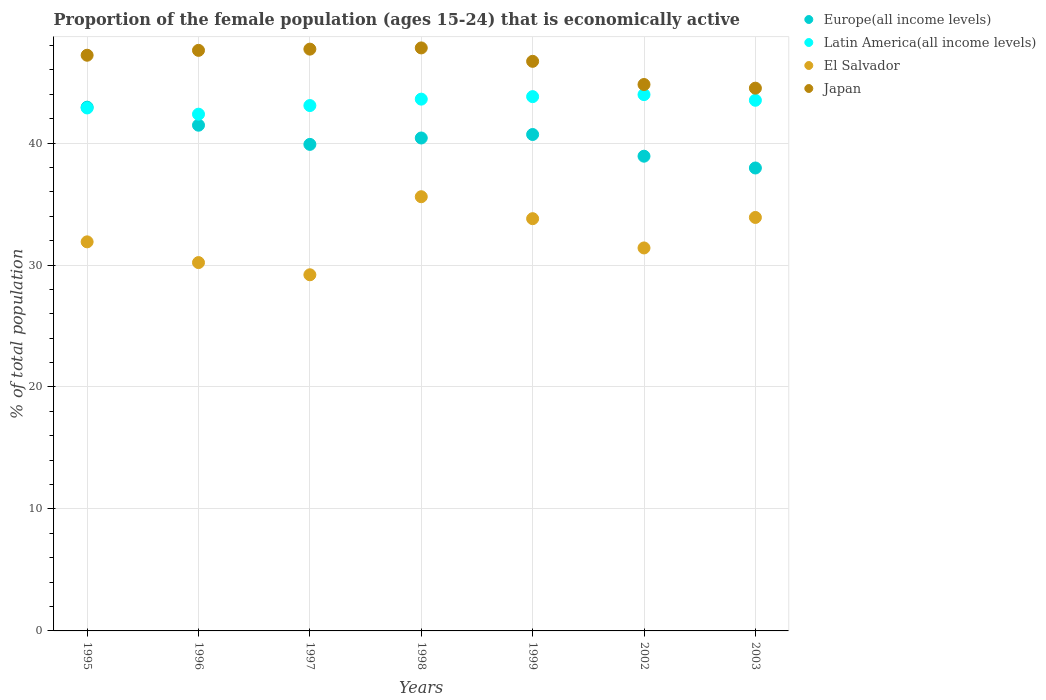How many different coloured dotlines are there?
Provide a short and direct response. 4. Is the number of dotlines equal to the number of legend labels?
Offer a very short reply. Yes. What is the proportion of the female population that is economically active in Latin America(all income levels) in 1996?
Give a very brief answer. 42.37. Across all years, what is the maximum proportion of the female population that is economically active in El Salvador?
Offer a very short reply. 35.6. Across all years, what is the minimum proportion of the female population that is economically active in El Salvador?
Offer a very short reply. 29.2. What is the total proportion of the female population that is economically active in Japan in the graph?
Keep it short and to the point. 326.3. What is the difference between the proportion of the female population that is economically active in Europe(all income levels) in 1996 and that in 1997?
Your response must be concise. 1.57. What is the difference between the proportion of the female population that is economically active in Europe(all income levels) in 2003 and the proportion of the female population that is economically active in Japan in 1999?
Your response must be concise. -8.74. What is the average proportion of the female population that is economically active in Latin America(all income levels) per year?
Offer a terse response. 43.31. In the year 1995, what is the difference between the proportion of the female population that is economically active in Japan and proportion of the female population that is economically active in Europe(all income levels)?
Your answer should be compact. 4.26. In how many years, is the proportion of the female population that is economically active in Europe(all income levels) greater than 10 %?
Offer a very short reply. 7. What is the ratio of the proportion of the female population that is economically active in Europe(all income levels) in 1996 to that in 1999?
Your answer should be compact. 1.02. What is the difference between the highest and the second highest proportion of the female population that is economically active in Europe(all income levels)?
Give a very brief answer. 1.48. What is the difference between the highest and the lowest proportion of the female population that is economically active in Latin America(all income levels)?
Your answer should be compact. 1.6. Is the sum of the proportion of the female population that is economically active in Europe(all income levels) in 1996 and 2002 greater than the maximum proportion of the female population that is economically active in El Salvador across all years?
Keep it short and to the point. Yes. Is it the case that in every year, the sum of the proportion of the female population that is economically active in Japan and proportion of the female population that is economically active in El Salvador  is greater than the sum of proportion of the female population that is economically active in Europe(all income levels) and proportion of the female population that is economically active in Latin America(all income levels)?
Offer a terse response. No. Is it the case that in every year, the sum of the proportion of the female population that is economically active in Japan and proportion of the female population that is economically active in El Salvador  is greater than the proportion of the female population that is economically active in Europe(all income levels)?
Make the answer very short. Yes. Does the proportion of the female population that is economically active in El Salvador monotonically increase over the years?
Your answer should be very brief. No. Is the proportion of the female population that is economically active in Japan strictly greater than the proportion of the female population that is economically active in Europe(all income levels) over the years?
Keep it short and to the point. Yes. Is the proportion of the female population that is economically active in El Salvador strictly less than the proportion of the female population that is economically active in Japan over the years?
Offer a terse response. Yes. How many dotlines are there?
Offer a very short reply. 4. How many years are there in the graph?
Your answer should be compact. 7. What is the difference between two consecutive major ticks on the Y-axis?
Offer a terse response. 10. Does the graph contain any zero values?
Give a very brief answer. No. Does the graph contain grids?
Give a very brief answer. Yes. Where does the legend appear in the graph?
Give a very brief answer. Top right. How many legend labels are there?
Your response must be concise. 4. What is the title of the graph?
Provide a short and direct response. Proportion of the female population (ages 15-24) that is economically active. Does "China" appear as one of the legend labels in the graph?
Your answer should be compact. No. What is the label or title of the Y-axis?
Provide a short and direct response. % of total population. What is the % of total population of Europe(all income levels) in 1995?
Your response must be concise. 42.94. What is the % of total population of Latin America(all income levels) in 1995?
Keep it short and to the point. 42.88. What is the % of total population of El Salvador in 1995?
Provide a short and direct response. 31.9. What is the % of total population in Japan in 1995?
Ensure brevity in your answer.  47.2. What is the % of total population of Europe(all income levels) in 1996?
Your answer should be very brief. 41.46. What is the % of total population of Latin America(all income levels) in 1996?
Make the answer very short. 42.37. What is the % of total population in El Salvador in 1996?
Provide a short and direct response. 30.2. What is the % of total population in Japan in 1996?
Your answer should be very brief. 47.6. What is the % of total population of Europe(all income levels) in 1997?
Make the answer very short. 39.89. What is the % of total population in Latin America(all income levels) in 1997?
Give a very brief answer. 43.07. What is the % of total population of El Salvador in 1997?
Ensure brevity in your answer.  29.2. What is the % of total population in Japan in 1997?
Make the answer very short. 47.7. What is the % of total population in Europe(all income levels) in 1998?
Keep it short and to the point. 40.41. What is the % of total population in Latin America(all income levels) in 1998?
Make the answer very short. 43.6. What is the % of total population of El Salvador in 1998?
Ensure brevity in your answer.  35.6. What is the % of total population of Japan in 1998?
Keep it short and to the point. 47.8. What is the % of total population in Europe(all income levels) in 1999?
Your answer should be very brief. 40.7. What is the % of total population in Latin America(all income levels) in 1999?
Keep it short and to the point. 43.81. What is the % of total population of El Salvador in 1999?
Ensure brevity in your answer.  33.8. What is the % of total population of Japan in 1999?
Offer a very short reply. 46.7. What is the % of total population of Europe(all income levels) in 2002?
Ensure brevity in your answer.  38.92. What is the % of total population in Latin America(all income levels) in 2002?
Your answer should be compact. 43.97. What is the % of total population in El Salvador in 2002?
Your answer should be compact. 31.4. What is the % of total population in Japan in 2002?
Give a very brief answer. 44.8. What is the % of total population in Europe(all income levels) in 2003?
Make the answer very short. 37.96. What is the % of total population in Latin America(all income levels) in 2003?
Make the answer very short. 43.51. What is the % of total population in El Salvador in 2003?
Provide a succinct answer. 33.9. What is the % of total population in Japan in 2003?
Offer a very short reply. 44.5. Across all years, what is the maximum % of total population in Europe(all income levels)?
Provide a succinct answer. 42.94. Across all years, what is the maximum % of total population in Latin America(all income levels)?
Offer a very short reply. 43.97. Across all years, what is the maximum % of total population in El Salvador?
Provide a short and direct response. 35.6. Across all years, what is the maximum % of total population of Japan?
Make the answer very short. 47.8. Across all years, what is the minimum % of total population of Europe(all income levels)?
Make the answer very short. 37.96. Across all years, what is the minimum % of total population in Latin America(all income levels)?
Your answer should be very brief. 42.37. Across all years, what is the minimum % of total population in El Salvador?
Make the answer very short. 29.2. Across all years, what is the minimum % of total population of Japan?
Make the answer very short. 44.5. What is the total % of total population in Europe(all income levels) in the graph?
Keep it short and to the point. 282.29. What is the total % of total population in Latin America(all income levels) in the graph?
Ensure brevity in your answer.  303.2. What is the total % of total population in El Salvador in the graph?
Your response must be concise. 226. What is the total % of total population of Japan in the graph?
Provide a succinct answer. 326.3. What is the difference between the % of total population in Europe(all income levels) in 1995 and that in 1996?
Your answer should be very brief. 1.48. What is the difference between the % of total population in Latin America(all income levels) in 1995 and that in 1996?
Ensure brevity in your answer.  0.51. What is the difference between the % of total population of Japan in 1995 and that in 1996?
Offer a very short reply. -0.4. What is the difference between the % of total population in Europe(all income levels) in 1995 and that in 1997?
Give a very brief answer. 3.05. What is the difference between the % of total population of Latin America(all income levels) in 1995 and that in 1997?
Keep it short and to the point. -0.2. What is the difference between the % of total population in El Salvador in 1995 and that in 1997?
Give a very brief answer. 2.7. What is the difference between the % of total population in Japan in 1995 and that in 1997?
Provide a succinct answer. -0.5. What is the difference between the % of total population in Europe(all income levels) in 1995 and that in 1998?
Provide a short and direct response. 2.53. What is the difference between the % of total population in Latin America(all income levels) in 1995 and that in 1998?
Keep it short and to the point. -0.72. What is the difference between the % of total population of Japan in 1995 and that in 1998?
Ensure brevity in your answer.  -0.6. What is the difference between the % of total population of Europe(all income levels) in 1995 and that in 1999?
Your answer should be compact. 2.24. What is the difference between the % of total population of Latin America(all income levels) in 1995 and that in 1999?
Provide a short and direct response. -0.93. What is the difference between the % of total population in Europe(all income levels) in 1995 and that in 2002?
Your response must be concise. 4.02. What is the difference between the % of total population in Latin America(all income levels) in 1995 and that in 2002?
Provide a short and direct response. -1.09. What is the difference between the % of total population of Japan in 1995 and that in 2002?
Provide a succinct answer. 2.4. What is the difference between the % of total population of Europe(all income levels) in 1995 and that in 2003?
Provide a succinct answer. 4.99. What is the difference between the % of total population of Latin America(all income levels) in 1995 and that in 2003?
Give a very brief answer. -0.63. What is the difference between the % of total population of El Salvador in 1995 and that in 2003?
Ensure brevity in your answer.  -2. What is the difference between the % of total population in Europe(all income levels) in 1996 and that in 1997?
Offer a very short reply. 1.57. What is the difference between the % of total population in Latin America(all income levels) in 1996 and that in 1997?
Your response must be concise. -0.71. What is the difference between the % of total population in Europe(all income levels) in 1996 and that in 1998?
Your answer should be compact. 1.05. What is the difference between the % of total population in Latin America(all income levels) in 1996 and that in 1998?
Provide a short and direct response. -1.23. What is the difference between the % of total population in Japan in 1996 and that in 1998?
Provide a succinct answer. -0.2. What is the difference between the % of total population of Europe(all income levels) in 1996 and that in 1999?
Your response must be concise. 0.76. What is the difference between the % of total population in Latin America(all income levels) in 1996 and that in 1999?
Provide a succinct answer. -1.44. What is the difference between the % of total population in El Salvador in 1996 and that in 1999?
Offer a terse response. -3.6. What is the difference between the % of total population of Japan in 1996 and that in 1999?
Provide a succinct answer. 0.9. What is the difference between the % of total population of Europe(all income levels) in 1996 and that in 2002?
Give a very brief answer. 2.54. What is the difference between the % of total population in Latin America(all income levels) in 1996 and that in 2002?
Your answer should be very brief. -1.6. What is the difference between the % of total population in El Salvador in 1996 and that in 2002?
Make the answer very short. -1.2. What is the difference between the % of total population in Japan in 1996 and that in 2002?
Your answer should be very brief. 2.8. What is the difference between the % of total population in Europe(all income levels) in 1996 and that in 2003?
Provide a short and direct response. 3.51. What is the difference between the % of total population of Latin America(all income levels) in 1996 and that in 2003?
Make the answer very short. -1.14. What is the difference between the % of total population in El Salvador in 1996 and that in 2003?
Make the answer very short. -3.7. What is the difference between the % of total population in Japan in 1996 and that in 2003?
Your response must be concise. 3.1. What is the difference between the % of total population of Europe(all income levels) in 1997 and that in 1998?
Your answer should be very brief. -0.52. What is the difference between the % of total population of Latin America(all income levels) in 1997 and that in 1998?
Give a very brief answer. -0.53. What is the difference between the % of total population of El Salvador in 1997 and that in 1998?
Your answer should be very brief. -6.4. What is the difference between the % of total population of Japan in 1997 and that in 1998?
Give a very brief answer. -0.1. What is the difference between the % of total population of Europe(all income levels) in 1997 and that in 1999?
Your answer should be compact. -0.81. What is the difference between the % of total population in Latin America(all income levels) in 1997 and that in 1999?
Your answer should be very brief. -0.73. What is the difference between the % of total population of El Salvador in 1997 and that in 1999?
Your answer should be compact. -4.6. What is the difference between the % of total population of Japan in 1997 and that in 1999?
Your answer should be compact. 1. What is the difference between the % of total population in Europe(all income levels) in 1997 and that in 2002?
Make the answer very short. 0.97. What is the difference between the % of total population of Latin America(all income levels) in 1997 and that in 2002?
Give a very brief answer. -0.9. What is the difference between the % of total population in El Salvador in 1997 and that in 2002?
Your response must be concise. -2.2. What is the difference between the % of total population in Japan in 1997 and that in 2002?
Your answer should be very brief. 2.9. What is the difference between the % of total population of Europe(all income levels) in 1997 and that in 2003?
Provide a short and direct response. 1.93. What is the difference between the % of total population in Latin America(all income levels) in 1997 and that in 2003?
Ensure brevity in your answer.  -0.43. What is the difference between the % of total population of El Salvador in 1997 and that in 2003?
Ensure brevity in your answer.  -4.7. What is the difference between the % of total population in Japan in 1997 and that in 2003?
Provide a short and direct response. 3.2. What is the difference between the % of total population in Europe(all income levels) in 1998 and that in 1999?
Give a very brief answer. -0.29. What is the difference between the % of total population in Latin America(all income levels) in 1998 and that in 1999?
Make the answer very short. -0.21. What is the difference between the % of total population in Japan in 1998 and that in 1999?
Your answer should be very brief. 1.1. What is the difference between the % of total population in Europe(all income levels) in 1998 and that in 2002?
Your response must be concise. 1.49. What is the difference between the % of total population in Latin America(all income levels) in 1998 and that in 2002?
Ensure brevity in your answer.  -0.37. What is the difference between the % of total population of El Salvador in 1998 and that in 2002?
Ensure brevity in your answer.  4.2. What is the difference between the % of total population in Europe(all income levels) in 1998 and that in 2003?
Your answer should be compact. 2.46. What is the difference between the % of total population in Latin America(all income levels) in 1998 and that in 2003?
Your answer should be compact. 0.09. What is the difference between the % of total population in El Salvador in 1998 and that in 2003?
Provide a succinct answer. 1.7. What is the difference between the % of total population in Japan in 1998 and that in 2003?
Provide a succinct answer. 3.3. What is the difference between the % of total population in Europe(all income levels) in 1999 and that in 2002?
Offer a very short reply. 1.78. What is the difference between the % of total population of Latin America(all income levels) in 1999 and that in 2002?
Offer a terse response. -0.17. What is the difference between the % of total population of El Salvador in 1999 and that in 2002?
Provide a succinct answer. 2.4. What is the difference between the % of total population in Japan in 1999 and that in 2002?
Your answer should be very brief. 1.9. What is the difference between the % of total population of Europe(all income levels) in 1999 and that in 2003?
Keep it short and to the point. 2.75. What is the difference between the % of total population of Latin America(all income levels) in 1999 and that in 2003?
Give a very brief answer. 0.3. What is the difference between the % of total population of Europe(all income levels) in 2002 and that in 2003?
Your response must be concise. 0.97. What is the difference between the % of total population of Latin America(all income levels) in 2002 and that in 2003?
Your response must be concise. 0.46. What is the difference between the % of total population in Japan in 2002 and that in 2003?
Your answer should be compact. 0.3. What is the difference between the % of total population in Europe(all income levels) in 1995 and the % of total population in Latin America(all income levels) in 1996?
Provide a succinct answer. 0.57. What is the difference between the % of total population in Europe(all income levels) in 1995 and the % of total population in El Salvador in 1996?
Your answer should be very brief. 12.74. What is the difference between the % of total population of Europe(all income levels) in 1995 and the % of total population of Japan in 1996?
Provide a succinct answer. -4.66. What is the difference between the % of total population of Latin America(all income levels) in 1995 and the % of total population of El Salvador in 1996?
Provide a succinct answer. 12.68. What is the difference between the % of total population of Latin America(all income levels) in 1995 and the % of total population of Japan in 1996?
Make the answer very short. -4.72. What is the difference between the % of total population in El Salvador in 1995 and the % of total population in Japan in 1996?
Offer a very short reply. -15.7. What is the difference between the % of total population of Europe(all income levels) in 1995 and the % of total population of Latin America(all income levels) in 1997?
Provide a succinct answer. -0.13. What is the difference between the % of total population of Europe(all income levels) in 1995 and the % of total population of El Salvador in 1997?
Keep it short and to the point. 13.74. What is the difference between the % of total population in Europe(all income levels) in 1995 and the % of total population in Japan in 1997?
Your answer should be very brief. -4.76. What is the difference between the % of total population of Latin America(all income levels) in 1995 and the % of total population of El Salvador in 1997?
Your answer should be very brief. 13.68. What is the difference between the % of total population of Latin America(all income levels) in 1995 and the % of total population of Japan in 1997?
Make the answer very short. -4.82. What is the difference between the % of total population of El Salvador in 1995 and the % of total population of Japan in 1997?
Provide a succinct answer. -15.8. What is the difference between the % of total population of Europe(all income levels) in 1995 and the % of total population of Latin America(all income levels) in 1998?
Keep it short and to the point. -0.66. What is the difference between the % of total population of Europe(all income levels) in 1995 and the % of total population of El Salvador in 1998?
Provide a succinct answer. 7.34. What is the difference between the % of total population of Europe(all income levels) in 1995 and the % of total population of Japan in 1998?
Keep it short and to the point. -4.86. What is the difference between the % of total population in Latin America(all income levels) in 1995 and the % of total population in El Salvador in 1998?
Provide a succinct answer. 7.28. What is the difference between the % of total population in Latin America(all income levels) in 1995 and the % of total population in Japan in 1998?
Provide a short and direct response. -4.92. What is the difference between the % of total population of El Salvador in 1995 and the % of total population of Japan in 1998?
Offer a terse response. -15.9. What is the difference between the % of total population of Europe(all income levels) in 1995 and the % of total population of Latin America(all income levels) in 1999?
Ensure brevity in your answer.  -0.87. What is the difference between the % of total population in Europe(all income levels) in 1995 and the % of total population in El Salvador in 1999?
Your answer should be compact. 9.14. What is the difference between the % of total population in Europe(all income levels) in 1995 and the % of total population in Japan in 1999?
Ensure brevity in your answer.  -3.76. What is the difference between the % of total population of Latin America(all income levels) in 1995 and the % of total population of El Salvador in 1999?
Offer a terse response. 9.08. What is the difference between the % of total population of Latin America(all income levels) in 1995 and the % of total population of Japan in 1999?
Provide a short and direct response. -3.82. What is the difference between the % of total population of El Salvador in 1995 and the % of total population of Japan in 1999?
Your response must be concise. -14.8. What is the difference between the % of total population in Europe(all income levels) in 1995 and the % of total population in Latin America(all income levels) in 2002?
Your answer should be compact. -1.03. What is the difference between the % of total population in Europe(all income levels) in 1995 and the % of total population in El Salvador in 2002?
Your response must be concise. 11.54. What is the difference between the % of total population of Europe(all income levels) in 1995 and the % of total population of Japan in 2002?
Make the answer very short. -1.86. What is the difference between the % of total population of Latin America(all income levels) in 1995 and the % of total population of El Salvador in 2002?
Your answer should be compact. 11.48. What is the difference between the % of total population in Latin America(all income levels) in 1995 and the % of total population in Japan in 2002?
Give a very brief answer. -1.92. What is the difference between the % of total population of Europe(all income levels) in 1995 and the % of total population of Latin America(all income levels) in 2003?
Make the answer very short. -0.57. What is the difference between the % of total population in Europe(all income levels) in 1995 and the % of total population in El Salvador in 2003?
Your answer should be compact. 9.04. What is the difference between the % of total population of Europe(all income levels) in 1995 and the % of total population of Japan in 2003?
Offer a terse response. -1.56. What is the difference between the % of total population of Latin America(all income levels) in 1995 and the % of total population of El Salvador in 2003?
Provide a succinct answer. 8.98. What is the difference between the % of total population of Latin America(all income levels) in 1995 and the % of total population of Japan in 2003?
Give a very brief answer. -1.62. What is the difference between the % of total population in El Salvador in 1995 and the % of total population in Japan in 2003?
Your response must be concise. -12.6. What is the difference between the % of total population in Europe(all income levels) in 1996 and the % of total population in Latin America(all income levels) in 1997?
Keep it short and to the point. -1.61. What is the difference between the % of total population of Europe(all income levels) in 1996 and the % of total population of El Salvador in 1997?
Offer a terse response. 12.26. What is the difference between the % of total population of Europe(all income levels) in 1996 and the % of total population of Japan in 1997?
Give a very brief answer. -6.24. What is the difference between the % of total population of Latin America(all income levels) in 1996 and the % of total population of El Salvador in 1997?
Your response must be concise. 13.17. What is the difference between the % of total population of Latin America(all income levels) in 1996 and the % of total population of Japan in 1997?
Provide a succinct answer. -5.33. What is the difference between the % of total population of El Salvador in 1996 and the % of total population of Japan in 1997?
Give a very brief answer. -17.5. What is the difference between the % of total population in Europe(all income levels) in 1996 and the % of total population in Latin America(all income levels) in 1998?
Provide a short and direct response. -2.14. What is the difference between the % of total population of Europe(all income levels) in 1996 and the % of total population of El Salvador in 1998?
Provide a short and direct response. 5.86. What is the difference between the % of total population of Europe(all income levels) in 1996 and the % of total population of Japan in 1998?
Provide a short and direct response. -6.34. What is the difference between the % of total population in Latin America(all income levels) in 1996 and the % of total population in El Salvador in 1998?
Offer a very short reply. 6.77. What is the difference between the % of total population of Latin America(all income levels) in 1996 and the % of total population of Japan in 1998?
Your response must be concise. -5.43. What is the difference between the % of total population of El Salvador in 1996 and the % of total population of Japan in 1998?
Offer a very short reply. -17.6. What is the difference between the % of total population in Europe(all income levels) in 1996 and the % of total population in Latin America(all income levels) in 1999?
Provide a succinct answer. -2.34. What is the difference between the % of total population in Europe(all income levels) in 1996 and the % of total population in El Salvador in 1999?
Give a very brief answer. 7.66. What is the difference between the % of total population of Europe(all income levels) in 1996 and the % of total population of Japan in 1999?
Give a very brief answer. -5.24. What is the difference between the % of total population of Latin America(all income levels) in 1996 and the % of total population of El Salvador in 1999?
Make the answer very short. 8.57. What is the difference between the % of total population in Latin America(all income levels) in 1996 and the % of total population in Japan in 1999?
Your answer should be compact. -4.33. What is the difference between the % of total population of El Salvador in 1996 and the % of total population of Japan in 1999?
Provide a short and direct response. -16.5. What is the difference between the % of total population of Europe(all income levels) in 1996 and the % of total population of Latin America(all income levels) in 2002?
Your answer should be very brief. -2.51. What is the difference between the % of total population in Europe(all income levels) in 1996 and the % of total population in El Salvador in 2002?
Offer a very short reply. 10.06. What is the difference between the % of total population of Europe(all income levels) in 1996 and the % of total population of Japan in 2002?
Keep it short and to the point. -3.34. What is the difference between the % of total population of Latin America(all income levels) in 1996 and the % of total population of El Salvador in 2002?
Ensure brevity in your answer.  10.97. What is the difference between the % of total population in Latin America(all income levels) in 1996 and the % of total population in Japan in 2002?
Your response must be concise. -2.43. What is the difference between the % of total population of El Salvador in 1996 and the % of total population of Japan in 2002?
Make the answer very short. -14.6. What is the difference between the % of total population of Europe(all income levels) in 1996 and the % of total population of Latin America(all income levels) in 2003?
Ensure brevity in your answer.  -2.04. What is the difference between the % of total population in Europe(all income levels) in 1996 and the % of total population in El Salvador in 2003?
Offer a terse response. 7.56. What is the difference between the % of total population of Europe(all income levels) in 1996 and the % of total population of Japan in 2003?
Your answer should be compact. -3.04. What is the difference between the % of total population of Latin America(all income levels) in 1996 and the % of total population of El Salvador in 2003?
Offer a very short reply. 8.47. What is the difference between the % of total population in Latin America(all income levels) in 1996 and the % of total population in Japan in 2003?
Your answer should be compact. -2.13. What is the difference between the % of total population in El Salvador in 1996 and the % of total population in Japan in 2003?
Ensure brevity in your answer.  -14.3. What is the difference between the % of total population in Europe(all income levels) in 1997 and the % of total population in Latin America(all income levels) in 1998?
Offer a terse response. -3.71. What is the difference between the % of total population of Europe(all income levels) in 1997 and the % of total population of El Salvador in 1998?
Ensure brevity in your answer.  4.29. What is the difference between the % of total population of Europe(all income levels) in 1997 and the % of total population of Japan in 1998?
Keep it short and to the point. -7.91. What is the difference between the % of total population in Latin America(all income levels) in 1997 and the % of total population in El Salvador in 1998?
Offer a terse response. 7.47. What is the difference between the % of total population in Latin America(all income levels) in 1997 and the % of total population in Japan in 1998?
Offer a very short reply. -4.73. What is the difference between the % of total population in El Salvador in 1997 and the % of total population in Japan in 1998?
Provide a short and direct response. -18.6. What is the difference between the % of total population of Europe(all income levels) in 1997 and the % of total population of Latin America(all income levels) in 1999?
Provide a short and direct response. -3.92. What is the difference between the % of total population of Europe(all income levels) in 1997 and the % of total population of El Salvador in 1999?
Provide a short and direct response. 6.09. What is the difference between the % of total population in Europe(all income levels) in 1997 and the % of total population in Japan in 1999?
Your response must be concise. -6.81. What is the difference between the % of total population in Latin America(all income levels) in 1997 and the % of total population in El Salvador in 1999?
Your response must be concise. 9.27. What is the difference between the % of total population of Latin America(all income levels) in 1997 and the % of total population of Japan in 1999?
Give a very brief answer. -3.63. What is the difference between the % of total population in El Salvador in 1997 and the % of total population in Japan in 1999?
Make the answer very short. -17.5. What is the difference between the % of total population in Europe(all income levels) in 1997 and the % of total population in Latin America(all income levels) in 2002?
Offer a very short reply. -4.08. What is the difference between the % of total population in Europe(all income levels) in 1997 and the % of total population in El Salvador in 2002?
Offer a terse response. 8.49. What is the difference between the % of total population in Europe(all income levels) in 1997 and the % of total population in Japan in 2002?
Give a very brief answer. -4.91. What is the difference between the % of total population of Latin America(all income levels) in 1997 and the % of total population of El Salvador in 2002?
Your answer should be compact. 11.67. What is the difference between the % of total population in Latin America(all income levels) in 1997 and the % of total population in Japan in 2002?
Offer a terse response. -1.73. What is the difference between the % of total population of El Salvador in 1997 and the % of total population of Japan in 2002?
Give a very brief answer. -15.6. What is the difference between the % of total population in Europe(all income levels) in 1997 and the % of total population in Latin America(all income levels) in 2003?
Provide a short and direct response. -3.62. What is the difference between the % of total population in Europe(all income levels) in 1997 and the % of total population in El Salvador in 2003?
Keep it short and to the point. 5.99. What is the difference between the % of total population of Europe(all income levels) in 1997 and the % of total population of Japan in 2003?
Ensure brevity in your answer.  -4.61. What is the difference between the % of total population in Latin America(all income levels) in 1997 and the % of total population in El Salvador in 2003?
Your response must be concise. 9.17. What is the difference between the % of total population in Latin America(all income levels) in 1997 and the % of total population in Japan in 2003?
Provide a succinct answer. -1.43. What is the difference between the % of total population of El Salvador in 1997 and the % of total population of Japan in 2003?
Your answer should be very brief. -15.3. What is the difference between the % of total population in Europe(all income levels) in 1998 and the % of total population in Latin America(all income levels) in 1999?
Your answer should be very brief. -3.39. What is the difference between the % of total population in Europe(all income levels) in 1998 and the % of total population in El Salvador in 1999?
Your answer should be compact. 6.61. What is the difference between the % of total population of Europe(all income levels) in 1998 and the % of total population of Japan in 1999?
Provide a short and direct response. -6.29. What is the difference between the % of total population in Latin America(all income levels) in 1998 and the % of total population in El Salvador in 1999?
Offer a very short reply. 9.8. What is the difference between the % of total population of Latin America(all income levels) in 1998 and the % of total population of Japan in 1999?
Your answer should be very brief. -3.1. What is the difference between the % of total population in Europe(all income levels) in 1998 and the % of total population in Latin America(all income levels) in 2002?
Provide a short and direct response. -3.56. What is the difference between the % of total population of Europe(all income levels) in 1998 and the % of total population of El Salvador in 2002?
Provide a short and direct response. 9.01. What is the difference between the % of total population of Europe(all income levels) in 1998 and the % of total population of Japan in 2002?
Offer a terse response. -4.39. What is the difference between the % of total population in Latin America(all income levels) in 1998 and the % of total population in El Salvador in 2002?
Your response must be concise. 12.2. What is the difference between the % of total population of Latin America(all income levels) in 1998 and the % of total population of Japan in 2002?
Your answer should be compact. -1.2. What is the difference between the % of total population in Europe(all income levels) in 1998 and the % of total population in Latin America(all income levels) in 2003?
Give a very brief answer. -3.09. What is the difference between the % of total population in Europe(all income levels) in 1998 and the % of total population in El Salvador in 2003?
Offer a very short reply. 6.51. What is the difference between the % of total population in Europe(all income levels) in 1998 and the % of total population in Japan in 2003?
Provide a succinct answer. -4.09. What is the difference between the % of total population in Latin America(all income levels) in 1998 and the % of total population in El Salvador in 2003?
Offer a terse response. 9.7. What is the difference between the % of total population in Latin America(all income levels) in 1998 and the % of total population in Japan in 2003?
Your answer should be very brief. -0.9. What is the difference between the % of total population of El Salvador in 1998 and the % of total population of Japan in 2003?
Make the answer very short. -8.9. What is the difference between the % of total population of Europe(all income levels) in 1999 and the % of total population of Latin America(all income levels) in 2002?
Ensure brevity in your answer.  -3.27. What is the difference between the % of total population in Europe(all income levels) in 1999 and the % of total population in El Salvador in 2002?
Offer a very short reply. 9.3. What is the difference between the % of total population in Europe(all income levels) in 1999 and the % of total population in Japan in 2002?
Your answer should be very brief. -4.1. What is the difference between the % of total population in Latin America(all income levels) in 1999 and the % of total population in El Salvador in 2002?
Your answer should be very brief. 12.41. What is the difference between the % of total population in Latin America(all income levels) in 1999 and the % of total population in Japan in 2002?
Offer a very short reply. -0.99. What is the difference between the % of total population of Europe(all income levels) in 1999 and the % of total population of Latin America(all income levels) in 2003?
Your answer should be very brief. -2.81. What is the difference between the % of total population of Europe(all income levels) in 1999 and the % of total population of El Salvador in 2003?
Provide a succinct answer. 6.8. What is the difference between the % of total population in Europe(all income levels) in 1999 and the % of total population in Japan in 2003?
Your answer should be compact. -3.8. What is the difference between the % of total population of Latin America(all income levels) in 1999 and the % of total population of El Salvador in 2003?
Your response must be concise. 9.91. What is the difference between the % of total population in Latin America(all income levels) in 1999 and the % of total population in Japan in 2003?
Offer a terse response. -0.69. What is the difference between the % of total population in El Salvador in 1999 and the % of total population in Japan in 2003?
Give a very brief answer. -10.7. What is the difference between the % of total population in Europe(all income levels) in 2002 and the % of total population in Latin America(all income levels) in 2003?
Your response must be concise. -4.58. What is the difference between the % of total population of Europe(all income levels) in 2002 and the % of total population of El Salvador in 2003?
Your answer should be very brief. 5.02. What is the difference between the % of total population in Europe(all income levels) in 2002 and the % of total population in Japan in 2003?
Give a very brief answer. -5.58. What is the difference between the % of total population of Latin America(all income levels) in 2002 and the % of total population of El Salvador in 2003?
Offer a very short reply. 10.07. What is the difference between the % of total population in Latin America(all income levels) in 2002 and the % of total population in Japan in 2003?
Ensure brevity in your answer.  -0.53. What is the average % of total population in Europe(all income levels) per year?
Offer a terse response. 40.33. What is the average % of total population in Latin America(all income levels) per year?
Offer a very short reply. 43.31. What is the average % of total population of El Salvador per year?
Make the answer very short. 32.29. What is the average % of total population in Japan per year?
Ensure brevity in your answer.  46.61. In the year 1995, what is the difference between the % of total population in Europe(all income levels) and % of total population in Latin America(all income levels)?
Give a very brief answer. 0.06. In the year 1995, what is the difference between the % of total population in Europe(all income levels) and % of total population in El Salvador?
Your answer should be very brief. 11.04. In the year 1995, what is the difference between the % of total population of Europe(all income levels) and % of total population of Japan?
Your response must be concise. -4.26. In the year 1995, what is the difference between the % of total population of Latin America(all income levels) and % of total population of El Salvador?
Provide a short and direct response. 10.98. In the year 1995, what is the difference between the % of total population in Latin America(all income levels) and % of total population in Japan?
Provide a short and direct response. -4.32. In the year 1995, what is the difference between the % of total population in El Salvador and % of total population in Japan?
Provide a succinct answer. -15.3. In the year 1996, what is the difference between the % of total population of Europe(all income levels) and % of total population of Latin America(all income levels)?
Your response must be concise. -0.9. In the year 1996, what is the difference between the % of total population in Europe(all income levels) and % of total population in El Salvador?
Ensure brevity in your answer.  11.26. In the year 1996, what is the difference between the % of total population of Europe(all income levels) and % of total population of Japan?
Offer a terse response. -6.14. In the year 1996, what is the difference between the % of total population of Latin America(all income levels) and % of total population of El Salvador?
Ensure brevity in your answer.  12.17. In the year 1996, what is the difference between the % of total population of Latin America(all income levels) and % of total population of Japan?
Ensure brevity in your answer.  -5.23. In the year 1996, what is the difference between the % of total population of El Salvador and % of total population of Japan?
Provide a succinct answer. -17.4. In the year 1997, what is the difference between the % of total population of Europe(all income levels) and % of total population of Latin America(all income levels)?
Ensure brevity in your answer.  -3.18. In the year 1997, what is the difference between the % of total population in Europe(all income levels) and % of total population in El Salvador?
Offer a terse response. 10.69. In the year 1997, what is the difference between the % of total population of Europe(all income levels) and % of total population of Japan?
Ensure brevity in your answer.  -7.81. In the year 1997, what is the difference between the % of total population in Latin America(all income levels) and % of total population in El Salvador?
Your response must be concise. 13.87. In the year 1997, what is the difference between the % of total population of Latin America(all income levels) and % of total population of Japan?
Your answer should be compact. -4.63. In the year 1997, what is the difference between the % of total population of El Salvador and % of total population of Japan?
Provide a succinct answer. -18.5. In the year 1998, what is the difference between the % of total population of Europe(all income levels) and % of total population of Latin America(all income levels)?
Ensure brevity in your answer.  -3.19. In the year 1998, what is the difference between the % of total population of Europe(all income levels) and % of total population of El Salvador?
Your response must be concise. 4.81. In the year 1998, what is the difference between the % of total population in Europe(all income levels) and % of total population in Japan?
Make the answer very short. -7.39. In the year 1998, what is the difference between the % of total population of Latin America(all income levels) and % of total population of El Salvador?
Make the answer very short. 8. In the year 1998, what is the difference between the % of total population in Latin America(all income levels) and % of total population in Japan?
Keep it short and to the point. -4.2. In the year 1998, what is the difference between the % of total population of El Salvador and % of total population of Japan?
Provide a short and direct response. -12.2. In the year 1999, what is the difference between the % of total population in Europe(all income levels) and % of total population in Latin America(all income levels)?
Make the answer very short. -3.11. In the year 1999, what is the difference between the % of total population in Europe(all income levels) and % of total population in El Salvador?
Offer a very short reply. 6.9. In the year 1999, what is the difference between the % of total population of Europe(all income levels) and % of total population of Japan?
Provide a short and direct response. -6. In the year 1999, what is the difference between the % of total population in Latin America(all income levels) and % of total population in El Salvador?
Provide a short and direct response. 10.01. In the year 1999, what is the difference between the % of total population of Latin America(all income levels) and % of total population of Japan?
Your response must be concise. -2.89. In the year 1999, what is the difference between the % of total population in El Salvador and % of total population in Japan?
Offer a very short reply. -12.9. In the year 2002, what is the difference between the % of total population in Europe(all income levels) and % of total population in Latin America(all income levels)?
Keep it short and to the point. -5.05. In the year 2002, what is the difference between the % of total population of Europe(all income levels) and % of total population of El Salvador?
Your answer should be very brief. 7.52. In the year 2002, what is the difference between the % of total population of Europe(all income levels) and % of total population of Japan?
Provide a short and direct response. -5.88. In the year 2002, what is the difference between the % of total population of Latin America(all income levels) and % of total population of El Salvador?
Your answer should be very brief. 12.57. In the year 2002, what is the difference between the % of total population in Latin America(all income levels) and % of total population in Japan?
Your answer should be very brief. -0.83. In the year 2002, what is the difference between the % of total population of El Salvador and % of total population of Japan?
Give a very brief answer. -13.4. In the year 2003, what is the difference between the % of total population in Europe(all income levels) and % of total population in Latin America(all income levels)?
Keep it short and to the point. -5.55. In the year 2003, what is the difference between the % of total population in Europe(all income levels) and % of total population in El Salvador?
Ensure brevity in your answer.  4.06. In the year 2003, what is the difference between the % of total population of Europe(all income levels) and % of total population of Japan?
Keep it short and to the point. -6.54. In the year 2003, what is the difference between the % of total population of Latin America(all income levels) and % of total population of El Salvador?
Provide a short and direct response. 9.61. In the year 2003, what is the difference between the % of total population in Latin America(all income levels) and % of total population in Japan?
Your response must be concise. -0.99. What is the ratio of the % of total population in Europe(all income levels) in 1995 to that in 1996?
Ensure brevity in your answer.  1.04. What is the ratio of the % of total population of Latin America(all income levels) in 1995 to that in 1996?
Make the answer very short. 1.01. What is the ratio of the % of total population of El Salvador in 1995 to that in 1996?
Your answer should be compact. 1.06. What is the ratio of the % of total population of Europe(all income levels) in 1995 to that in 1997?
Offer a very short reply. 1.08. What is the ratio of the % of total population of Latin America(all income levels) in 1995 to that in 1997?
Keep it short and to the point. 1. What is the ratio of the % of total population of El Salvador in 1995 to that in 1997?
Offer a terse response. 1.09. What is the ratio of the % of total population in Japan in 1995 to that in 1997?
Your answer should be very brief. 0.99. What is the ratio of the % of total population of Latin America(all income levels) in 1995 to that in 1998?
Your answer should be very brief. 0.98. What is the ratio of the % of total population in El Salvador in 1995 to that in 1998?
Ensure brevity in your answer.  0.9. What is the ratio of the % of total population of Japan in 1995 to that in 1998?
Offer a terse response. 0.99. What is the ratio of the % of total population in Europe(all income levels) in 1995 to that in 1999?
Your response must be concise. 1.05. What is the ratio of the % of total population in Latin America(all income levels) in 1995 to that in 1999?
Your answer should be very brief. 0.98. What is the ratio of the % of total population of El Salvador in 1995 to that in 1999?
Offer a very short reply. 0.94. What is the ratio of the % of total population in Japan in 1995 to that in 1999?
Keep it short and to the point. 1.01. What is the ratio of the % of total population of Europe(all income levels) in 1995 to that in 2002?
Your answer should be compact. 1.1. What is the ratio of the % of total population of Latin America(all income levels) in 1995 to that in 2002?
Your answer should be very brief. 0.98. What is the ratio of the % of total population of El Salvador in 1995 to that in 2002?
Keep it short and to the point. 1.02. What is the ratio of the % of total population of Japan in 1995 to that in 2002?
Give a very brief answer. 1.05. What is the ratio of the % of total population in Europe(all income levels) in 1995 to that in 2003?
Your answer should be very brief. 1.13. What is the ratio of the % of total population in Latin America(all income levels) in 1995 to that in 2003?
Offer a very short reply. 0.99. What is the ratio of the % of total population in El Salvador in 1995 to that in 2003?
Provide a short and direct response. 0.94. What is the ratio of the % of total population in Japan in 1995 to that in 2003?
Your response must be concise. 1.06. What is the ratio of the % of total population in Europe(all income levels) in 1996 to that in 1997?
Keep it short and to the point. 1.04. What is the ratio of the % of total population of Latin America(all income levels) in 1996 to that in 1997?
Make the answer very short. 0.98. What is the ratio of the % of total population of El Salvador in 1996 to that in 1997?
Provide a succinct answer. 1.03. What is the ratio of the % of total population of Europe(all income levels) in 1996 to that in 1998?
Offer a very short reply. 1.03. What is the ratio of the % of total population of Latin America(all income levels) in 1996 to that in 1998?
Your answer should be very brief. 0.97. What is the ratio of the % of total population in El Salvador in 1996 to that in 1998?
Your answer should be compact. 0.85. What is the ratio of the % of total population in Japan in 1996 to that in 1998?
Provide a short and direct response. 1. What is the ratio of the % of total population of Europe(all income levels) in 1996 to that in 1999?
Make the answer very short. 1.02. What is the ratio of the % of total population in Latin America(all income levels) in 1996 to that in 1999?
Your response must be concise. 0.97. What is the ratio of the % of total population of El Salvador in 1996 to that in 1999?
Keep it short and to the point. 0.89. What is the ratio of the % of total population of Japan in 1996 to that in 1999?
Ensure brevity in your answer.  1.02. What is the ratio of the % of total population of Europe(all income levels) in 1996 to that in 2002?
Ensure brevity in your answer.  1.07. What is the ratio of the % of total population in Latin America(all income levels) in 1996 to that in 2002?
Offer a terse response. 0.96. What is the ratio of the % of total population in El Salvador in 1996 to that in 2002?
Offer a terse response. 0.96. What is the ratio of the % of total population of Europe(all income levels) in 1996 to that in 2003?
Provide a succinct answer. 1.09. What is the ratio of the % of total population of Latin America(all income levels) in 1996 to that in 2003?
Ensure brevity in your answer.  0.97. What is the ratio of the % of total population in El Salvador in 1996 to that in 2003?
Provide a succinct answer. 0.89. What is the ratio of the % of total population of Japan in 1996 to that in 2003?
Your answer should be compact. 1.07. What is the ratio of the % of total population of Latin America(all income levels) in 1997 to that in 1998?
Provide a short and direct response. 0.99. What is the ratio of the % of total population of El Salvador in 1997 to that in 1998?
Make the answer very short. 0.82. What is the ratio of the % of total population of Europe(all income levels) in 1997 to that in 1999?
Offer a terse response. 0.98. What is the ratio of the % of total population of Latin America(all income levels) in 1997 to that in 1999?
Give a very brief answer. 0.98. What is the ratio of the % of total population of El Salvador in 1997 to that in 1999?
Keep it short and to the point. 0.86. What is the ratio of the % of total population in Japan in 1997 to that in 1999?
Make the answer very short. 1.02. What is the ratio of the % of total population of Europe(all income levels) in 1997 to that in 2002?
Offer a terse response. 1.02. What is the ratio of the % of total population in Latin America(all income levels) in 1997 to that in 2002?
Give a very brief answer. 0.98. What is the ratio of the % of total population in El Salvador in 1997 to that in 2002?
Offer a very short reply. 0.93. What is the ratio of the % of total population in Japan in 1997 to that in 2002?
Offer a terse response. 1.06. What is the ratio of the % of total population of Europe(all income levels) in 1997 to that in 2003?
Make the answer very short. 1.05. What is the ratio of the % of total population of El Salvador in 1997 to that in 2003?
Offer a terse response. 0.86. What is the ratio of the % of total population in Japan in 1997 to that in 2003?
Keep it short and to the point. 1.07. What is the ratio of the % of total population of Europe(all income levels) in 1998 to that in 1999?
Your answer should be very brief. 0.99. What is the ratio of the % of total population in Latin America(all income levels) in 1998 to that in 1999?
Your answer should be very brief. 1. What is the ratio of the % of total population of El Salvador in 1998 to that in 1999?
Give a very brief answer. 1.05. What is the ratio of the % of total population in Japan in 1998 to that in 1999?
Your answer should be compact. 1.02. What is the ratio of the % of total population of Europe(all income levels) in 1998 to that in 2002?
Provide a short and direct response. 1.04. What is the ratio of the % of total population in Latin America(all income levels) in 1998 to that in 2002?
Offer a terse response. 0.99. What is the ratio of the % of total population in El Salvador in 1998 to that in 2002?
Offer a terse response. 1.13. What is the ratio of the % of total population of Japan in 1998 to that in 2002?
Provide a short and direct response. 1.07. What is the ratio of the % of total population in Europe(all income levels) in 1998 to that in 2003?
Give a very brief answer. 1.06. What is the ratio of the % of total population of El Salvador in 1998 to that in 2003?
Offer a terse response. 1.05. What is the ratio of the % of total population in Japan in 1998 to that in 2003?
Keep it short and to the point. 1.07. What is the ratio of the % of total population of Europe(all income levels) in 1999 to that in 2002?
Provide a succinct answer. 1.05. What is the ratio of the % of total population of El Salvador in 1999 to that in 2002?
Offer a very short reply. 1.08. What is the ratio of the % of total population in Japan in 1999 to that in 2002?
Your answer should be compact. 1.04. What is the ratio of the % of total population in Europe(all income levels) in 1999 to that in 2003?
Your answer should be compact. 1.07. What is the ratio of the % of total population of Japan in 1999 to that in 2003?
Your answer should be compact. 1.05. What is the ratio of the % of total population of Europe(all income levels) in 2002 to that in 2003?
Your answer should be very brief. 1.03. What is the ratio of the % of total population in Latin America(all income levels) in 2002 to that in 2003?
Provide a short and direct response. 1.01. What is the ratio of the % of total population in El Salvador in 2002 to that in 2003?
Provide a short and direct response. 0.93. What is the ratio of the % of total population in Japan in 2002 to that in 2003?
Offer a very short reply. 1.01. What is the difference between the highest and the second highest % of total population in Europe(all income levels)?
Ensure brevity in your answer.  1.48. What is the difference between the highest and the second highest % of total population in Latin America(all income levels)?
Your answer should be very brief. 0.17. What is the difference between the highest and the second highest % of total population in El Salvador?
Provide a succinct answer. 1.7. What is the difference between the highest and the second highest % of total population in Japan?
Your answer should be compact. 0.1. What is the difference between the highest and the lowest % of total population in Europe(all income levels)?
Provide a short and direct response. 4.99. What is the difference between the highest and the lowest % of total population of Latin America(all income levels)?
Your response must be concise. 1.6. What is the difference between the highest and the lowest % of total population of El Salvador?
Provide a short and direct response. 6.4. 